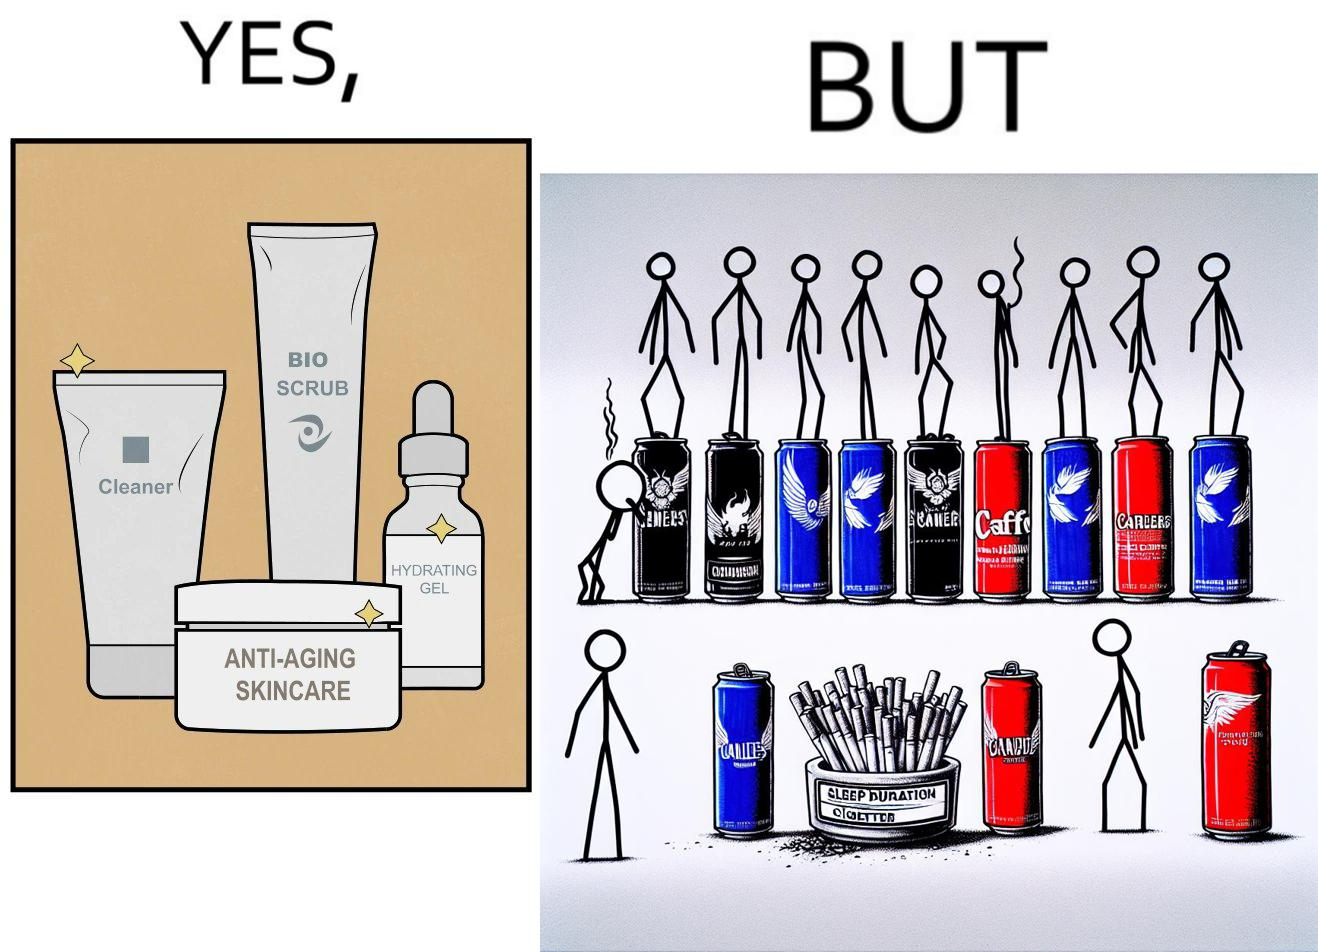What makes this image funny or satirical? This image is ironic as on the one hand, the presumed person is into skincare and wants to do the best for their skin, which is good, but on the other hand, they are involved in unhealthy habits that will damage their skin like smoking, caffeine and inadequate sleep. 